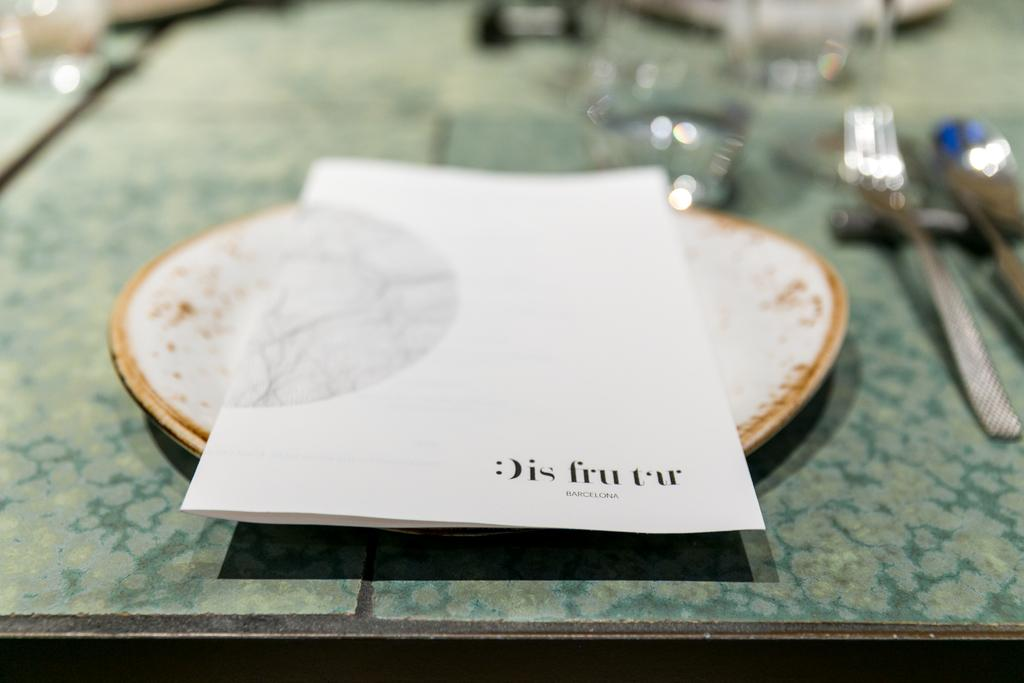What is placed on the plate in the image? The paper is placed on a plate in the image. Can you describe the objects on the right side of the image? Unfortunately, the provided facts do not give any information about the objects on the right side of the image. What type of joke is being told on the sofa in the image? There is no sofa or joke present in the image; it only features a paper placed on a plate. 